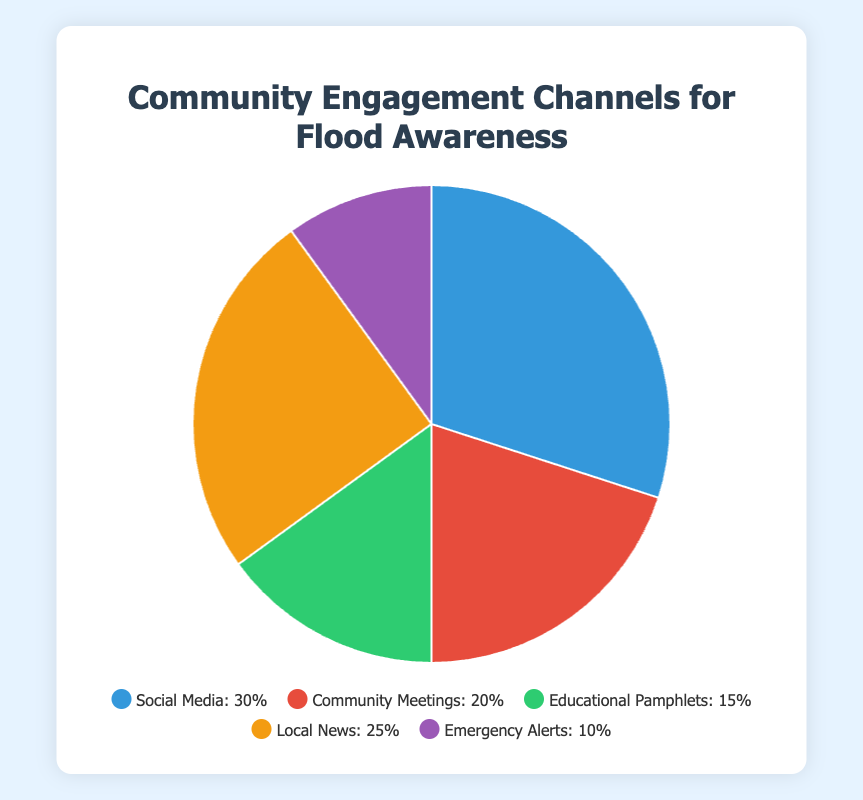What's the most popular community engagement channel for flood awareness? The segment representing Social Media is the largest, visually taking up 30% of the pie chart, making it the most popular channel.
Answer: Social Media What's the difference in percentage between the Local News and Emergency Alerts channels? Local News takes up 25% of the pie chart and Emergency Alerts take up 10%. The difference is calculated as 25 - 10.
Answer: 15% Which channel segment is represented in green? The green segment visually corresponds to Educational Pamphlets in the pie chart's legend.
Answer: Educational Pamphlets How do the combined percentages of Social Media and Local News compare to the total percentage? Social Media is 30% and Local News is 25%, combined they sum to 55%. The total pie chart adds to 100%, so 55% of the total is combined for these two channels.
Answer: 55% What is the percentage difference between the second and the third most popular channels? The second most popular is Local News at 25%, and the third is Community Meetings at 20%. Their percentage difference is 25 - 20.
Answer: 5% If County Libraries, Schools, and Local Government Offices are utilized for Educational Pamphlets, what percentage does this channel represent on the pie chart? The Educational Pamphlets segment is indicated as taking up 15% of the pie chart.
Answer: 15% Which channel has the smallest representation in the pie chart? The segment for Emergency Alerts is the smallest, visually representing 10% of the pie chart.
Answer: Emergency Alerts How much more popular is Social Media as a channel compared to Emergency Alerts? Social Media is 30% and Emergency Alerts is 10%, thus Social Media is 30 - 10 or 20% more popular than Emergency Alerts.
Answer: 20% What overall trend can be observed based on the distribution of the community engagement channels? The channels show a diverse spread with Social Media being the most dominant at 30%, followed by Local News at 25%, pointing towards a preference for digital and easily accessible formats. The least used is Emergency Alerts at 10%.
Answer: Diverse spread with a preference for digital formats 